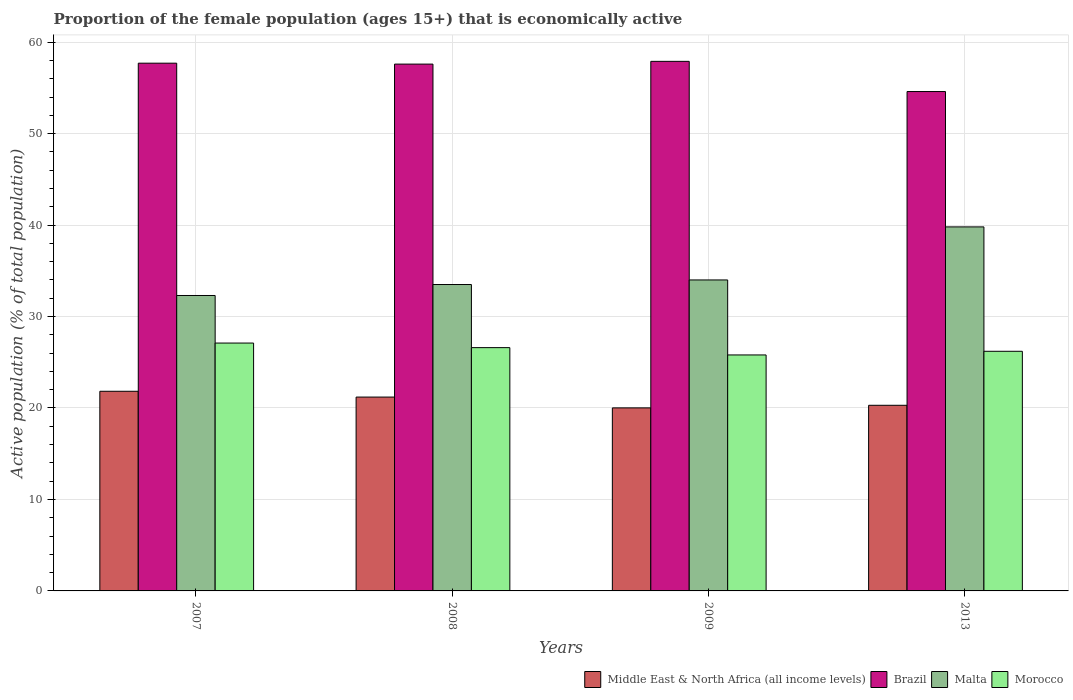How many different coloured bars are there?
Your answer should be compact. 4. Are the number of bars per tick equal to the number of legend labels?
Provide a short and direct response. Yes. Are the number of bars on each tick of the X-axis equal?
Provide a short and direct response. Yes. How many bars are there on the 4th tick from the left?
Provide a succinct answer. 4. How many bars are there on the 1st tick from the right?
Offer a terse response. 4. What is the proportion of the female population that is economically active in Brazil in 2008?
Your response must be concise. 57.6. Across all years, what is the maximum proportion of the female population that is economically active in Morocco?
Keep it short and to the point. 27.1. Across all years, what is the minimum proportion of the female population that is economically active in Morocco?
Ensure brevity in your answer.  25.8. In which year was the proportion of the female population that is economically active in Brazil maximum?
Ensure brevity in your answer.  2009. What is the total proportion of the female population that is economically active in Brazil in the graph?
Make the answer very short. 227.8. What is the difference between the proportion of the female population that is economically active in Middle East & North Africa (all income levels) in 2007 and that in 2008?
Offer a terse response. 0.63. What is the difference between the proportion of the female population that is economically active in Brazil in 2009 and the proportion of the female population that is economically active in Middle East & North Africa (all income levels) in 2013?
Make the answer very short. 37.6. What is the average proportion of the female population that is economically active in Malta per year?
Ensure brevity in your answer.  34.9. In the year 2008, what is the difference between the proportion of the female population that is economically active in Brazil and proportion of the female population that is economically active in Middle East & North Africa (all income levels)?
Provide a succinct answer. 36.41. What is the ratio of the proportion of the female population that is economically active in Brazil in 2007 to that in 2008?
Offer a very short reply. 1. Is the proportion of the female population that is economically active in Brazil in 2008 less than that in 2009?
Your answer should be very brief. Yes. What is the difference between the highest and the second highest proportion of the female population that is economically active in Brazil?
Provide a succinct answer. 0.2. What is the difference between the highest and the lowest proportion of the female population that is economically active in Morocco?
Your answer should be compact. 1.3. Is it the case that in every year, the sum of the proportion of the female population that is economically active in Morocco and proportion of the female population that is economically active in Malta is greater than the sum of proportion of the female population that is economically active in Middle East & North Africa (all income levels) and proportion of the female population that is economically active in Brazil?
Provide a succinct answer. Yes. What does the 2nd bar from the right in 2013 represents?
Your response must be concise. Malta. Are all the bars in the graph horizontal?
Your answer should be very brief. No. How many years are there in the graph?
Ensure brevity in your answer.  4. Does the graph contain grids?
Offer a terse response. Yes. What is the title of the graph?
Provide a short and direct response. Proportion of the female population (ages 15+) that is economically active. Does "Thailand" appear as one of the legend labels in the graph?
Your answer should be very brief. No. What is the label or title of the X-axis?
Make the answer very short. Years. What is the label or title of the Y-axis?
Offer a very short reply. Active population (% of total population). What is the Active population (% of total population) of Middle East & North Africa (all income levels) in 2007?
Your response must be concise. 21.83. What is the Active population (% of total population) of Brazil in 2007?
Provide a succinct answer. 57.7. What is the Active population (% of total population) in Malta in 2007?
Make the answer very short. 32.3. What is the Active population (% of total population) in Morocco in 2007?
Offer a terse response. 27.1. What is the Active population (% of total population) of Middle East & North Africa (all income levels) in 2008?
Keep it short and to the point. 21.19. What is the Active population (% of total population) in Brazil in 2008?
Provide a short and direct response. 57.6. What is the Active population (% of total population) in Malta in 2008?
Your answer should be very brief. 33.5. What is the Active population (% of total population) of Morocco in 2008?
Ensure brevity in your answer.  26.6. What is the Active population (% of total population) of Middle East & North Africa (all income levels) in 2009?
Provide a short and direct response. 20.01. What is the Active population (% of total population) in Brazil in 2009?
Keep it short and to the point. 57.9. What is the Active population (% of total population) of Malta in 2009?
Keep it short and to the point. 34. What is the Active population (% of total population) in Morocco in 2009?
Your answer should be compact. 25.8. What is the Active population (% of total population) of Middle East & North Africa (all income levels) in 2013?
Ensure brevity in your answer.  20.3. What is the Active population (% of total population) in Brazil in 2013?
Offer a terse response. 54.6. What is the Active population (% of total population) of Malta in 2013?
Offer a terse response. 39.8. What is the Active population (% of total population) of Morocco in 2013?
Ensure brevity in your answer.  26.2. Across all years, what is the maximum Active population (% of total population) in Middle East & North Africa (all income levels)?
Give a very brief answer. 21.83. Across all years, what is the maximum Active population (% of total population) of Brazil?
Keep it short and to the point. 57.9. Across all years, what is the maximum Active population (% of total population) of Malta?
Give a very brief answer. 39.8. Across all years, what is the maximum Active population (% of total population) of Morocco?
Make the answer very short. 27.1. Across all years, what is the minimum Active population (% of total population) in Middle East & North Africa (all income levels)?
Your answer should be very brief. 20.01. Across all years, what is the minimum Active population (% of total population) in Brazil?
Give a very brief answer. 54.6. Across all years, what is the minimum Active population (% of total population) of Malta?
Your answer should be compact. 32.3. Across all years, what is the minimum Active population (% of total population) in Morocco?
Your answer should be compact. 25.8. What is the total Active population (% of total population) of Middle East & North Africa (all income levels) in the graph?
Your answer should be very brief. 83.33. What is the total Active population (% of total population) in Brazil in the graph?
Give a very brief answer. 227.8. What is the total Active population (% of total population) of Malta in the graph?
Offer a very short reply. 139.6. What is the total Active population (% of total population) of Morocco in the graph?
Your answer should be compact. 105.7. What is the difference between the Active population (% of total population) in Middle East & North Africa (all income levels) in 2007 and that in 2008?
Your response must be concise. 0.63. What is the difference between the Active population (% of total population) in Morocco in 2007 and that in 2008?
Keep it short and to the point. 0.5. What is the difference between the Active population (% of total population) of Middle East & North Africa (all income levels) in 2007 and that in 2009?
Make the answer very short. 1.82. What is the difference between the Active population (% of total population) in Brazil in 2007 and that in 2009?
Provide a short and direct response. -0.2. What is the difference between the Active population (% of total population) of Middle East & North Africa (all income levels) in 2007 and that in 2013?
Offer a very short reply. 1.53. What is the difference between the Active population (% of total population) in Morocco in 2007 and that in 2013?
Your response must be concise. 0.9. What is the difference between the Active population (% of total population) in Middle East & North Africa (all income levels) in 2008 and that in 2009?
Your answer should be compact. 1.18. What is the difference between the Active population (% of total population) of Malta in 2008 and that in 2009?
Make the answer very short. -0.5. What is the difference between the Active population (% of total population) in Middle East & North Africa (all income levels) in 2008 and that in 2013?
Provide a succinct answer. 0.9. What is the difference between the Active population (% of total population) in Malta in 2008 and that in 2013?
Your response must be concise. -6.3. What is the difference between the Active population (% of total population) in Middle East & North Africa (all income levels) in 2009 and that in 2013?
Your answer should be very brief. -0.29. What is the difference between the Active population (% of total population) of Brazil in 2009 and that in 2013?
Your answer should be compact. 3.3. What is the difference between the Active population (% of total population) of Morocco in 2009 and that in 2013?
Make the answer very short. -0.4. What is the difference between the Active population (% of total population) of Middle East & North Africa (all income levels) in 2007 and the Active population (% of total population) of Brazil in 2008?
Provide a short and direct response. -35.77. What is the difference between the Active population (% of total population) in Middle East & North Africa (all income levels) in 2007 and the Active population (% of total population) in Malta in 2008?
Provide a short and direct response. -11.67. What is the difference between the Active population (% of total population) in Middle East & North Africa (all income levels) in 2007 and the Active population (% of total population) in Morocco in 2008?
Ensure brevity in your answer.  -4.77. What is the difference between the Active population (% of total population) of Brazil in 2007 and the Active population (% of total population) of Malta in 2008?
Give a very brief answer. 24.2. What is the difference between the Active population (% of total population) in Brazil in 2007 and the Active population (% of total population) in Morocco in 2008?
Your response must be concise. 31.1. What is the difference between the Active population (% of total population) in Middle East & North Africa (all income levels) in 2007 and the Active population (% of total population) in Brazil in 2009?
Your response must be concise. -36.07. What is the difference between the Active population (% of total population) in Middle East & North Africa (all income levels) in 2007 and the Active population (% of total population) in Malta in 2009?
Provide a short and direct response. -12.17. What is the difference between the Active population (% of total population) of Middle East & North Africa (all income levels) in 2007 and the Active population (% of total population) of Morocco in 2009?
Your response must be concise. -3.97. What is the difference between the Active population (% of total population) of Brazil in 2007 and the Active population (% of total population) of Malta in 2009?
Provide a succinct answer. 23.7. What is the difference between the Active population (% of total population) of Brazil in 2007 and the Active population (% of total population) of Morocco in 2009?
Ensure brevity in your answer.  31.9. What is the difference between the Active population (% of total population) of Middle East & North Africa (all income levels) in 2007 and the Active population (% of total population) of Brazil in 2013?
Your response must be concise. -32.77. What is the difference between the Active population (% of total population) of Middle East & North Africa (all income levels) in 2007 and the Active population (% of total population) of Malta in 2013?
Ensure brevity in your answer.  -17.97. What is the difference between the Active population (% of total population) in Middle East & North Africa (all income levels) in 2007 and the Active population (% of total population) in Morocco in 2013?
Offer a terse response. -4.37. What is the difference between the Active population (% of total population) of Brazil in 2007 and the Active population (% of total population) of Morocco in 2013?
Give a very brief answer. 31.5. What is the difference between the Active population (% of total population) of Malta in 2007 and the Active population (% of total population) of Morocco in 2013?
Your answer should be compact. 6.1. What is the difference between the Active population (% of total population) of Middle East & North Africa (all income levels) in 2008 and the Active population (% of total population) of Brazil in 2009?
Offer a terse response. -36.71. What is the difference between the Active population (% of total population) of Middle East & North Africa (all income levels) in 2008 and the Active population (% of total population) of Malta in 2009?
Offer a very short reply. -12.81. What is the difference between the Active population (% of total population) of Middle East & North Africa (all income levels) in 2008 and the Active population (% of total population) of Morocco in 2009?
Offer a very short reply. -4.61. What is the difference between the Active population (% of total population) of Brazil in 2008 and the Active population (% of total population) of Malta in 2009?
Offer a very short reply. 23.6. What is the difference between the Active population (% of total population) of Brazil in 2008 and the Active population (% of total population) of Morocco in 2009?
Provide a short and direct response. 31.8. What is the difference between the Active population (% of total population) in Malta in 2008 and the Active population (% of total population) in Morocco in 2009?
Provide a short and direct response. 7.7. What is the difference between the Active population (% of total population) in Middle East & North Africa (all income levels) in 2008 and the Active population (% of total population) in Brazil in 2013?
Offer a very short reply. -33.41. What is the difference between the Active population (% of total population) of Middle East & North Africa (all income levels) in 2008 and the Active population (% of total population) of Malta in 2013?
Offer a terse response. -18.61. What is the difference between the Active population (% of total population) in Middle East & North Africa (all income levels) in 2008 and the Active population (% of total population) in Morocco in 2013?
Your answer should be compact. -5.01. What is the difference between the Active population (% of total population) in Brazil in 2008 and the Active population (% of total population) in Morocco in 2013?
Provide a short and direct response. 31.4. What is the difference between the Active population (% of total population) of Malta in 2008 and the Active population (% of total population) of Morocco in 2013?
Offer a terse response. 7.3. What is the difference between the Active population (% of total population) of Middle East & North Africa (all income levels) in 2009 and the Active population (% of total population) of Brazil in 2013?
Offer a very short reply. -34.59. What is the difference between the Active population (% of total population) in Middle East & North Africa (all income levels) in 2009 and the Active population (% of total population) in Malta in 2013?
Your answer should be compact. -19.79. What is the difference between the Active population (% of total population) of Middle East & North Africa (all income levels) in 2009 and the Active population (% of total population) of Morocco in 2013?
Your answer should be very brief. -6.19. What is the difference between the Active population (% of total population) of Brazil in 2009 and the Active population (% of total population) of Malta in 2013?
Offer a terse response. 18.1. What is the difference between the Active population (% of total population) of Brazil in 2009 and the Active population (% of total population) of Morocco in 2013?
Offer a very short reply. 31.7. What is the average Active population (% of total population) of Middle East & North Africa (all income levels) per year?
Ensure brevity in your answer.  20.83. What is the average Active population (% of total population) of Brazil per year?
Offer a terse response. 56.95. What is the average Active population (% of total population) of Malta per year?
Your answer should be very brief. 34.9. What is the average Active population (% of total population) of Morocco per year?
Ensure brevity in your answer.  26.43. In the year 2007, what is the difference between the Active population (% of total population) in Middle East & North Africa (all income levels) and Active population (% of total population) in Brazil?
Your response must be concise. -35.87. In the year 2007, what is the difference between the Active population (% of total population) of Middle East & North Africa (all income levels) and Active population (% of total population) of Malta?
Your response must be concise. -10.47. In the year 2007, what is the difference between the Active population (% of total population) in Middle East & North Africa (all income levels) and Active population (% of total population) in Morocco?
Your answer should be compact. -5.27. In the year 2007, what is the difference between the Active population (% of total population) in Brazil and Active population (% of total population) in Malta?
Keep it short and to the point. 25.4. In the year 2007, what is the difference between the Active population (% of total population) of Brazil and Active population (% of total population) of Morocco?
Your answer should be compact. 30.6. In the year 2007, what is the difference between the Active population (% of total population) in Malta and Active population (% of total population) in Morocco?
Give a very brief answer. 5.2. In the year 2008, what is the difference between the Active population (% of total population) of Middle East & North Africa (all income levels) and Active population (% of total population) of Brazil?
Provide a short and direct response. -36.41. In the year 2008, what is the difference between the Active population (% of total population) in Middle East & North Africa (all income levels) and Active population (% of total population) in Malta?
Your answer should be compact. -12.31. In the year 2008, what is the difference between the Active population (% of total population) of Middle East & North Africa (all income levels) and Active population (% of total population) of Morocco?
Offer a very short reply. -5.41. In the year 2008, what is the difference between the Active population (% of total population) in Brazil and Active population (% of total population) in Malta?
Your response must be concise. 24.1. In the year 2008, what is the difference between the Active population (% of total population) in Brazil and Active population (% of total population) in Morocco?
Offer a very short reply. 31. In the year 2009, what is the difference between the Active population (% of total population) of Middle East & North Africa (all income levels) and Active population (% of total population) of Brazil?
Provide a short and direct response. -37.89. In the year 2009, what is the difference between the Active population (% of total population) in Middle East & North Africa (all income levels) and Active population (% of total population) in Malta?
Your answer should be compact. -13.99. In the year 2009, what is the difference between the Active population (% of total population) of Middle East & North Africa (all income levels) and Active population (% of total population) of Morocco?
Give a very brief answer. -5.79. In the year 2009, what is the difference between the Active population (% of total population) in Brazil and Active population (% of total population) in Malta?
Your answer should be very brief. 23.9. In the year 2009, what is the difference between the Active population (% of total population) in Brazil and Active population (% of total population) in Morocco?
Provide a short and direct response. 32.1. In the year 2009, what is the difference between the Active population (% of total population) in Malta and Active population (% of total population) in Morocco?
Your answer should be very brief. 8.2. In the year 2013, what is the difference between the Active population (% of total population) in Middle East & North Africa (all income levels) and Active population (% of total population) in Brazil?
Ensure brevity in your answer.  -34.3. In the year 2013, what is the difference between the Active population (% of total population) of Middle East & North Africa (all income levels) and Active population (% of total population) of Malta?
Provide a succinct answer. -19.5. In the year 2013, what is the difference between the Active population (% of total population) in Middle East & North Africa (all income levels) and Active population (% of total population) in Morocco?
Your answer should be compact. -5.9. In the year 2013, what is the difference between the Active population (% of total population) in Brazil and Active population (% of total population) in Malta?
Your response must be concise. 14.8. In the year 2013, what is the difference between the Active population (% of total population) of Brazil and Active population (% of total population) of Morocco?
Your answer should be very brief. 28.4. In the year 2013, what is the difference between the Active population (% of total population) of Malta and Active population (% of total population) of Morocco?
Ensure brevity in your answer.  13.6. What is the ratio of the Active population (% of total population) in Middle East & North Africa (all income levels) in 2007 to that in 2008?
Provide a succinct answer. 1.03. What is the ratio of the Active population (% of total population) in Brazil in 2007 to that in 2008?
Your answer should be very brief. 1. What is the ratio of the Active population (% of total population) in Malta in 2007 to that in 2008?
Keep it short and to the point. 0.96. What is the ratio of the Active population (% of total population) of Morocco in 2007 to that in 2008?
Offer a terse response. 1.02. What is the ratio of the Active population (% of total population) of Middle East & North Africa (all income levels) in 2007 to that in 2009?
Your response must be concise. 1.09. What is the ratio of the Active population (% of total population) of Morocco in 2007 to that in 2009?
Give a very brief answer. 1.05. What is the ratio of the Active population (% of total population) in Middle East & North Africa (all income levels) in 2007 to that in 2013?
Make the answer very short. 1.08. What is the ratio of the Active population (% of total population) of Brazil in 2007 to that in 2013?
Keep it short and to the point. 1.06. What is the ratio of the Active population (% of total population) in Malta in 2007 to that in 2013?
Provide a succinct answer. 0.81. What is the ratio of the Active population (% of total population) of Morocco in 2007 to that in 2013?
Provide a succinct answer. 1.03. What is the ratio of the Active population (% of total population) of Middle East & North Africa (all income levels) in 2008 to that in 2009?
Offer a very short reply. 1.06. What is the ratio of the Active population (% of total population) in Morocco in 2008 to that in 2009?
Keep it short and to the point. 1.03. What is the ratio of the Active population (% of total population) in Middle East & North Africa (all income levels) in 2008 to that in 2013?
Ensure brevity in your answer.  1.04. What is the ratio of the Active population (% of total population) of Brazil in 2008 to that in 2013?
Offer a terse response. 1.05. What is the ratio of the Active population (% of total population) of Malta in 2008 to that in 2013?
Provide a short and direct response. 0.84. What is the ratio of the Active population (% of total population) in Morocco in 2008 to that in 2013?
Offer a very short reply. 1.02. What is the ratio of the Active population (% of total population) in Middle East & North Africa (all income levels) in 2009 to that in 2013?
Ensure brevity in your answer.  0.99. What is the ratio of the Active population (% of total population) of Brazil in 2009 to that in 2013?
Provide a short and direct response. 1.06. What is the ratio of the Active population (% of total population) of Malta in 2009 to that in 2013?
Offer a very short reply. 0.85. What is the ratio of the Active population (% of total population) of Morocco in 2009 to that in 2013?
Give a very brief answer. 0.98. What is the difference between the highest and the second highest Active population (% of total population) of Middle East & North Africa (all income levels)?
Give a very brief answer. 0.63. What is the difference between the highest and the second highest Active population (% of total population) of Malta?
Keep it short and to the point. 5.8. What is the difference between the highest and the lowest Active population (% of total population) in Middle East & North Africa (all income levels)?
Ensure brevity in your answer.  1.82. 